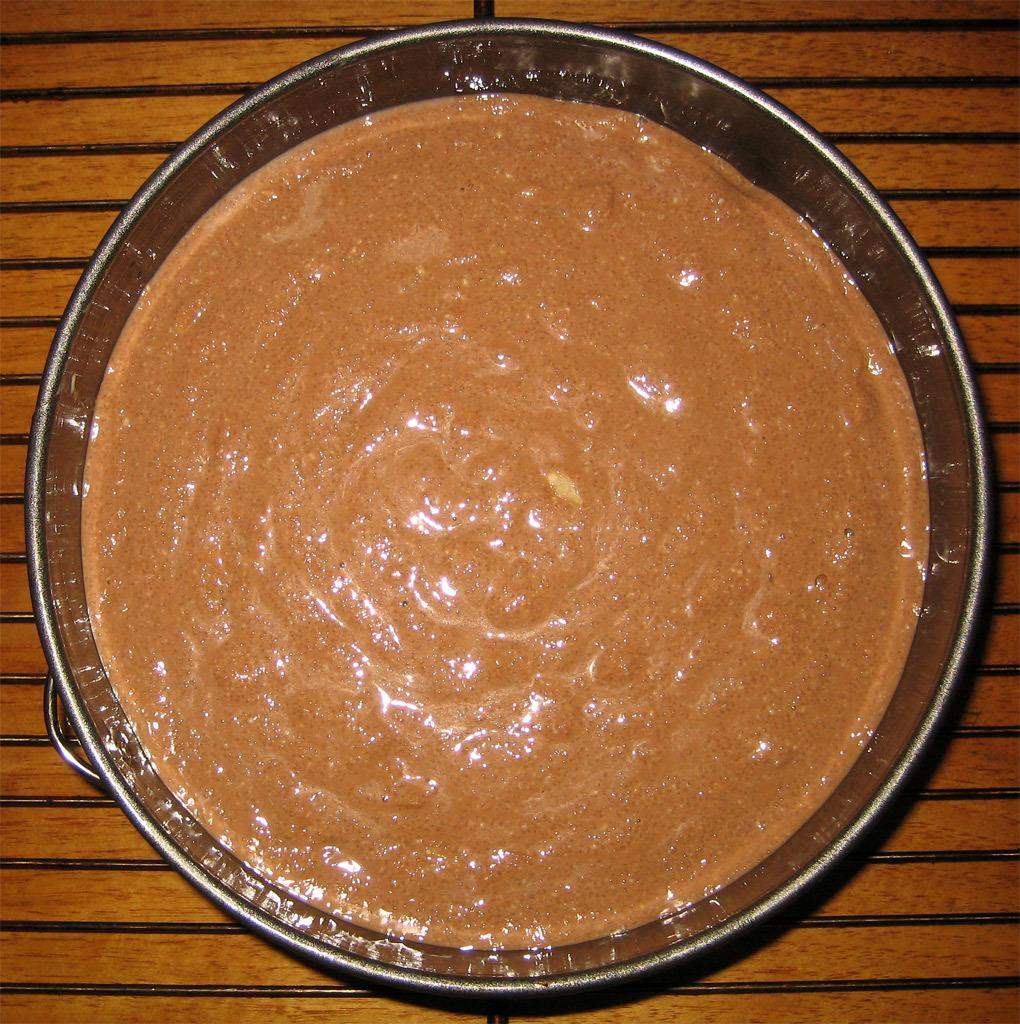What is present in the image? There is a bowl in the image. What is inside the bowl? There is an unspecified object in the bowl. What type of surface is visible at the bottom of the image? There is a wooden surface at the bottom of the image. Can you see any combs on the seashore in the image? There is no seashore or comb present in the image. What is the rate of expansion of the object in the bowl? The rate of expansion of the object in the bowl cannot be determined from the image, as there is no information about its properties or the context in which it is placed. 